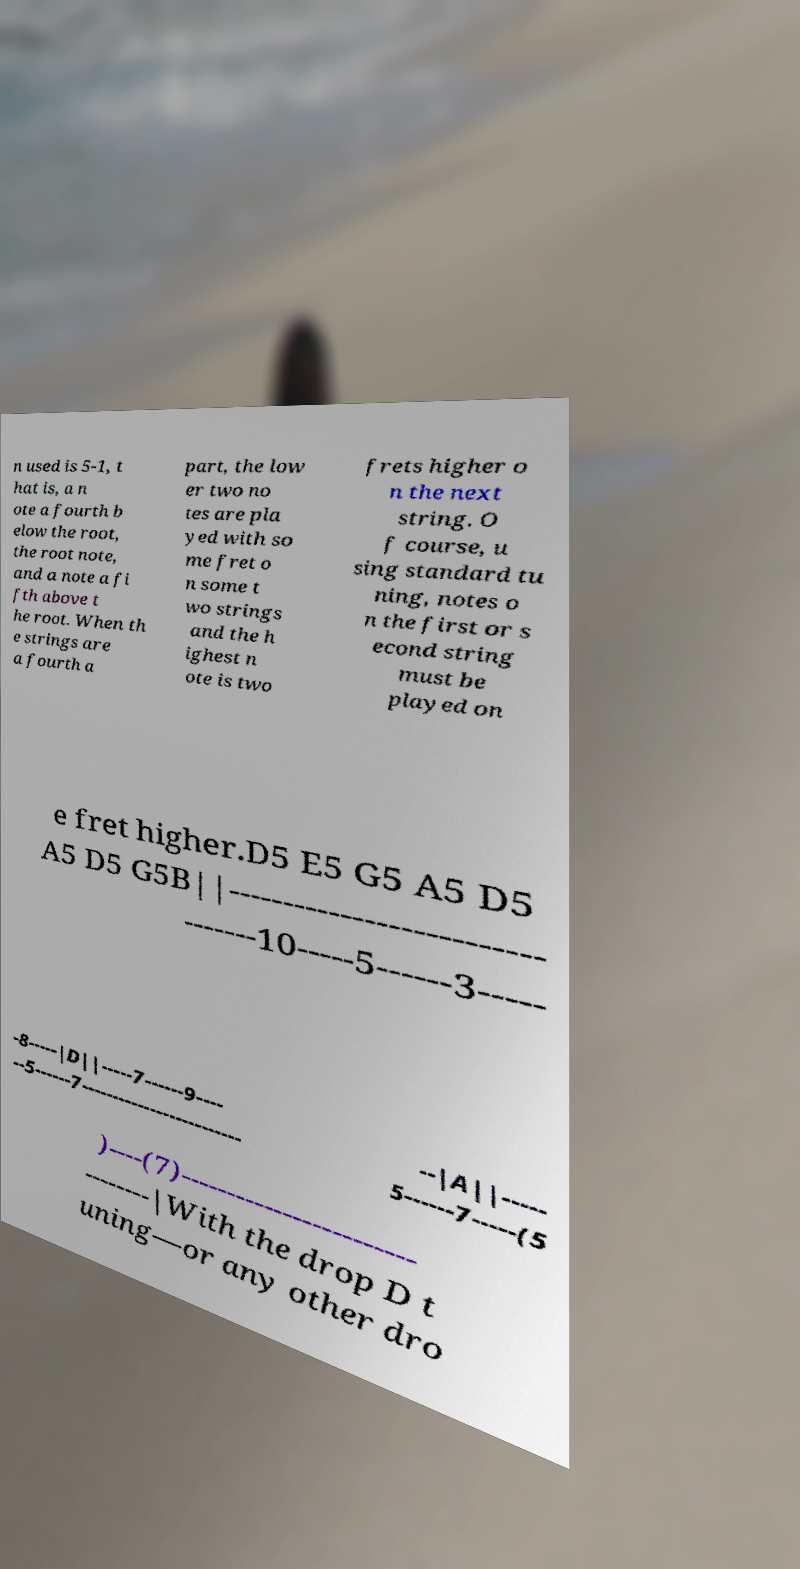Could you assist in decoding the text presented in this image and type it out clearly? n used is 5-1, t hat is, a n ote a fourth b elow the root, the root note, and a note a fi fth above t he root. When th e strings are a fourth a part, the low er two no tes are pla yed with so me fret o n some t wo strings and the h ighest n ote is two frets higher o n the next string. O f course, u sing standard tu ning, notes o n the first or s econd string must be played on e fret higher.D5 E5 G5 A5 D5 A5 D5 G5B||-------------------------- -------10-----5------3----- -8-----|D||-----7------9---- --5------7------------------------- --|A||----- 5------7-----(5 )----(7)------------------------ --------|With the drop D t uning—or any other dro 